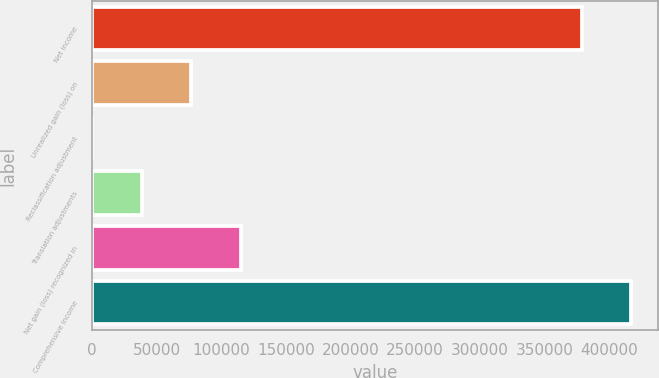Convert chart to OTSL. <chart><loc_0><loc_0><loc_500><loc_500><bar_chart><fcel>Net income<fcel>Unrealized gain (loss) on<fcel>Reclassification adjustment<fcel>Translation adjustments<fcel>Net gain (loss) recognized in<fcel>Comprehensive income<nl><fcel>379015<fcel>76636.4<fcel>3<fcel>38319.7<fcel>114953<fcel>417332<nl></chart> 